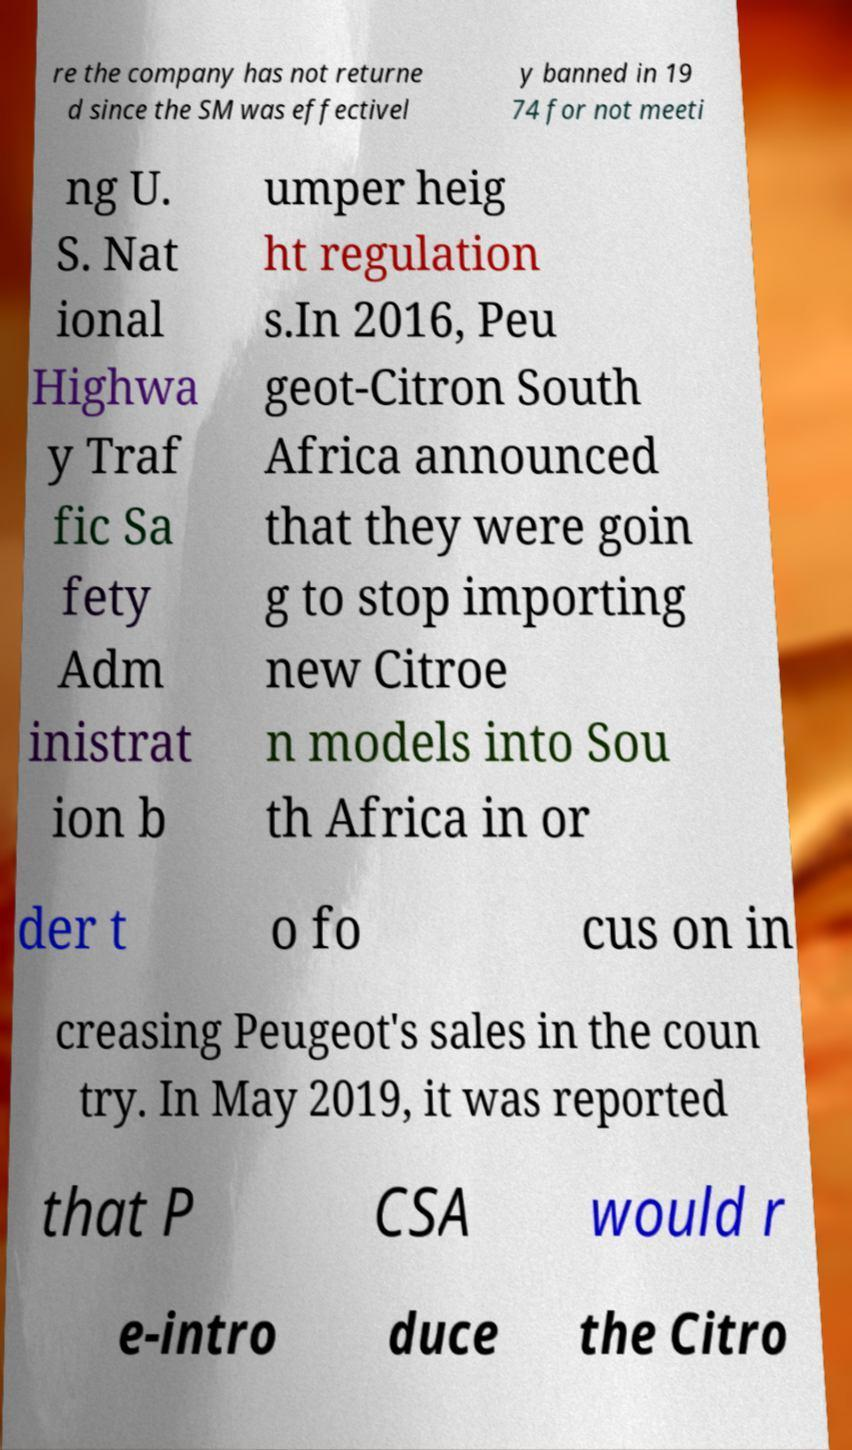Please identify and transcribe the text found in this image. re the company has not returne d since the SM was effectivel y banned in 19 74 for not meeti ng U. S. Nat ional Highwa y Traf fic Sa fety Adm inistrat ion b umper heig ht regulation s.In 2016, Peu geot-Citron South Africa announced that they were goin g to stop importing new Citroe n models into Sou th Africa in or der t o fo cus on in creasing Peugeot's sales in the coun try. In May 2019, it was reported that P CSA would r e-intro duce the Citro 